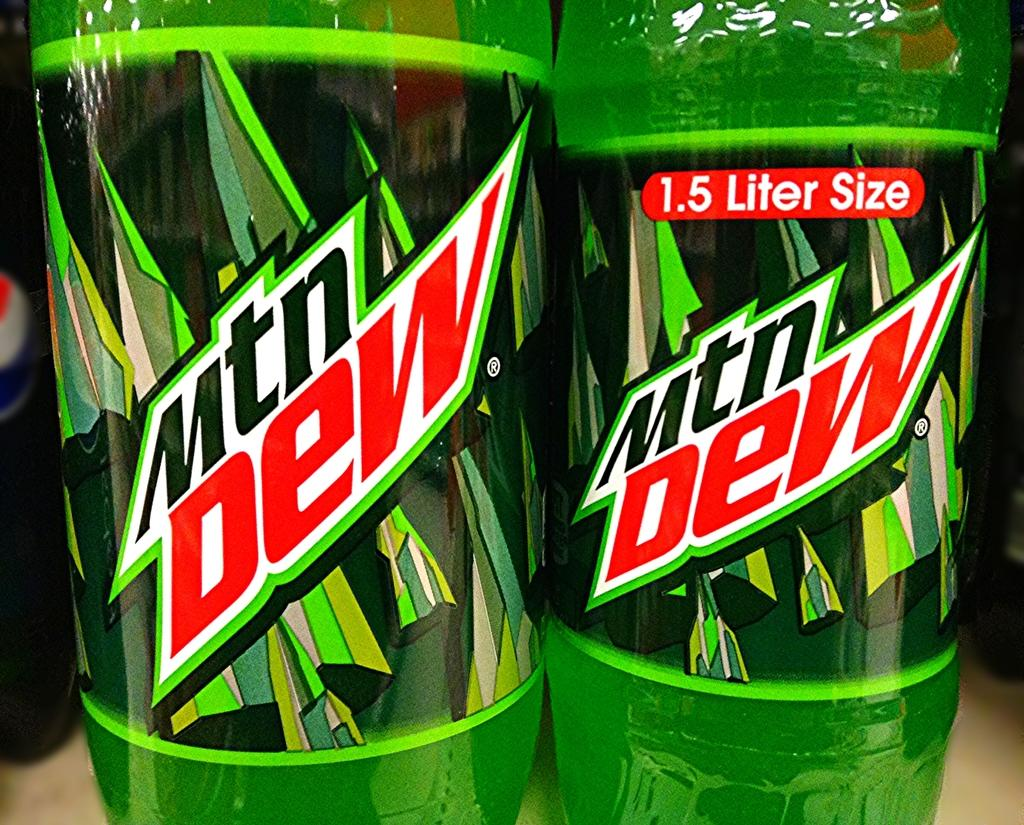What objects are present in the image that are green in color? There are two green color bottles in the image. Can you describe the shape of the bottles? The shape of the bottles cannot be determined from the provided facts. Are there any other objects in the image that are not green? The provided facts do not mention any other objects in the image. Is there a baby involved in a fight with the green bottles in the image? There is no mention of a baby or a fight in the image; it only features two green color bottles. 